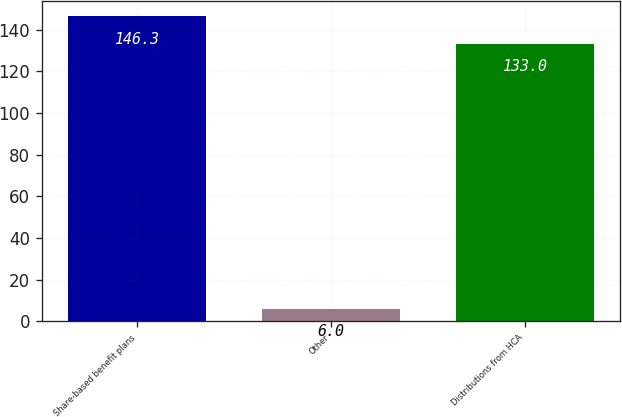Convert chart. <chart><loc_0><loc_0><loc_500><loc_500><bar_chart><fcel>Share-based benefit plans<fcel>Other<fcel>Distributions from HCA<nl><fcel>146.3<fcel>6<fcel>133<nl></chart> 